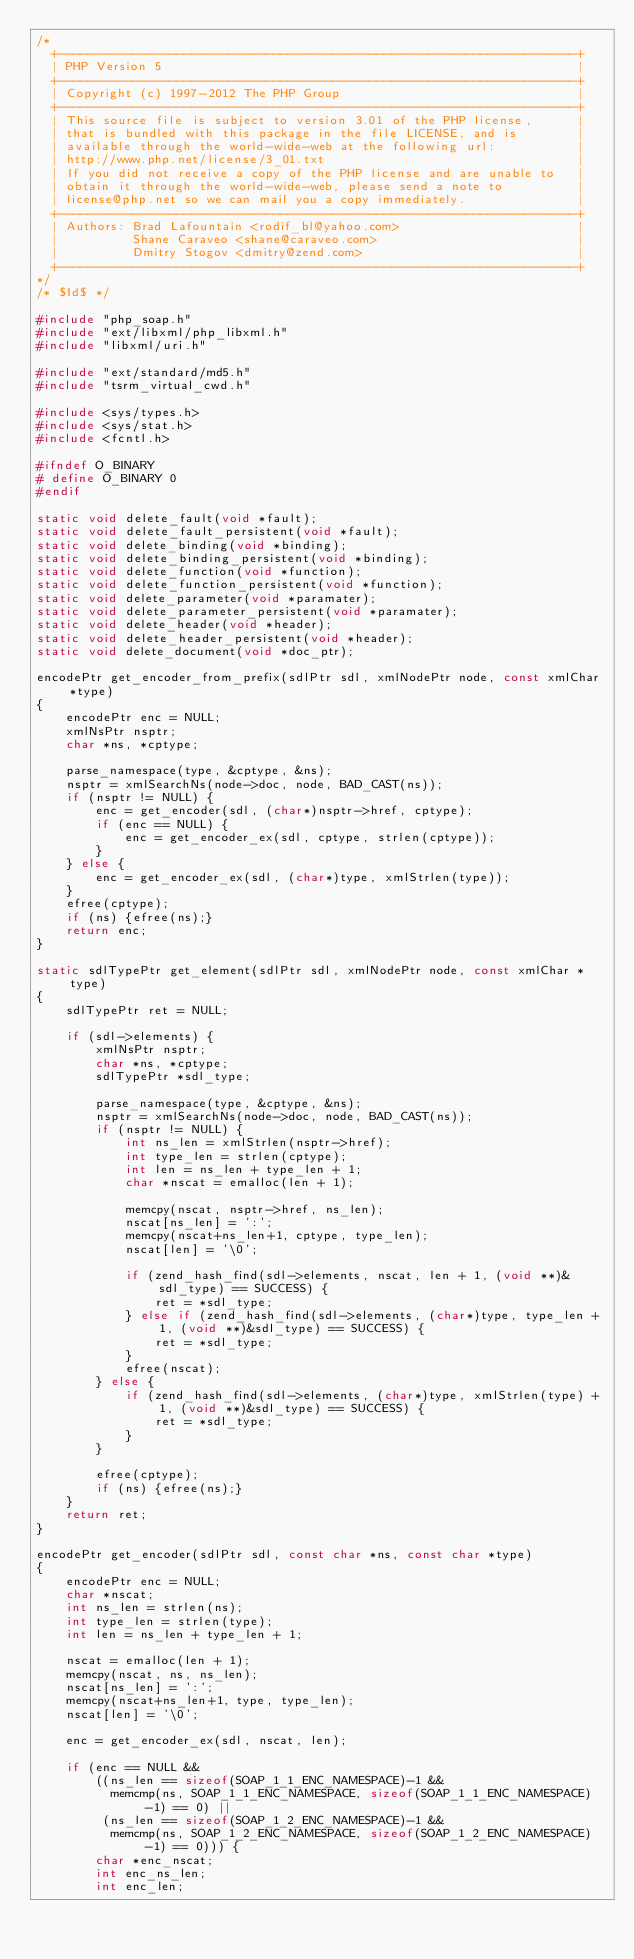Convert code to text. <code><loc_0><loc_0><loc_500><loc_500><_C_>/*
  +----------------------------------------------------------------------+
  | PHP Version 5                                                        |
  +----------------------------------------------------------------------+
  | Copyright (c) 1997-2012 The PHP Group                                |
  +----------------------------------------------------------------------+
  | This source file is subject to version 3.01 of the PHP license,      |
  | that is bundled with this package in the file LICENSE, and is        |
  | available through the world-wide-web at the following url:           |
  | http://www.php.net/license/3_01.txt                                  |
  | If you did not receive a copy of the PHP license and are unable to   |
  | obtain it through the world-wide-web, please send a note to          |
  | license@php.net so we can mail you a copy immediately.               |
  +----------------------------------------------------------------------+
  | Authors: Brad Lafountain <rodif_bl@yahoo.com>                        |
  |          Shane Caraveo <shane@caraveo.com>                           |
  |          Dmitry Stogov <dmitry@zend.com>                             |
  +----------------------------------------------------------------------+
*/
/* $Id$ */

#include "php_soap.h"
#include "ext/libxml/php_libxml.h"
#include "libxml/uri.h"

#include "ext/standard/md5.h"
#include "tsrm_virtual_cwd.h"

#include <sys/types.h>
#include <sys/stat.h>
#include <fcntl.h>

#ifndef O_BINARY
# define O_BINARY 0
#endif

static void delete_fault(void *fault);
static void delete_fault_persistent(void *fault);
static void delete_binding(void *binding);
static void delete_binding_persistent(void *binding);
static void delete_function(void *function);
static void delete_function_persistent(void *function);
static void delete_parameter(void *paramater);
static void delete_parameter_persistent(void *paramater);
static void delete_header(void *header);
static void delete_header_persistent(void *header);
static void delete_document(void *doc_ptr);

encodePtr get_encoder_from_prefix(sdlPtr sdl, xmlNodePtr node, const xmlChar *type)
{
	encodePtr enc = NULL;
	xmlNsPtr nsptr;
	char *ns, *cptype;

	parse_namespace(type, &cptype, &ns);
	nsptr = xmlSearchNs(node->doc, node, BAD_CAST(ns));
	if (nsptr != NULL) {
		enc = get_encoder(sdl, (char*)nsptr->href, cptype);
		if (enc == NULL) {
			enc = get_encoder_ex(sdl, cptype, strlen(cptype));
		}
	} else {
		enc = get_encoder_ex(sdl, (char*)type, xmlStrlen(type));
	}
	efree(cptype);
	if (ns) {efree(ns);}
	return enc;
}

static sdlTypePtr get_element(sdlPtr sdl, xmlNodePtr node, const xmlChar *type)
{
	sdlTypePtr ret = NULL;

	if (sdl->elements) {
		xmlNsPtr nsptr;
		char *ns, *cptype;
		sdlTypePtr *sdl_type;

		parse_namespace(type, &cptype, &ns);
		nsptr = xmlSearchNs(node->doc, node, BAD_CAST(ns));
		if (nsptr != NULL) {
			int ns_len = xmlStrlen(nsptr->href);
			int type_len = strlen(cptype);
			int len = ns_len + type_len + 1;
			char *nscat = emalloc(len + 1);

			memcpy(nscat, nsptr->href, ns_len);
			nscat[ns_len] = ':';
			memcpy(nscat+ns_len+1, cptype, type_len);
			nscat[len] = '\0';

			if (zend_hash_find(sdl->elements, nscat, len + 1, (void **)&sdl_type) == SUCCESS) {
				ret = *sdl_type;
			} else if (zend_hash_find(sdl->elements, (char*)type, type_len + 1, (void **)&sdl_type) == SUCCESS) {
				ret = *sdl_type;
			}
			efree(nscat);
		} else {
			if (zend_hash_find(sdl->elements, (char*)type, xmlStrlen(type) + 1, (void **)&sdl_type) == SUCCESS) {
				ret = *sdl_type;
			}
		}

		efree(cptype);
		if (ns) {efree(ns);}
	}
	return ret;
}

encodePtr get_encoder(sdlPtr sdl, const char *ns, const char *type)
{
	encodePtr enc = NULL;
	char *nscat;
	int ns_len = strlen(ns);
	int type_len = strlen(type);
	int len = ns_len + type_len + 1;

	nscat = emalloc(len + 1);
	memcpy(nscat, ns, ns_len);
	nscat[ns_len] = ':';
	memcpy(nscat+ns_len+1, type, type_len);
	nscat[len] = '\0';

	enc = get_encoder_ex(sdl, nscat, len);

	if (enc == NULL &&
	    ((ns_len == sizeof(SOAP_1_1_ENC_NAMESPACE)-1 &&
	      memcmp(ns, SOAP_1_1_ENC_NAMESPACE, sizeof(SOAP_1_1_ENC_NAMESPACE)-1) == 0) ||
	     (ns_len == sizeof(SOAP_1_2_ENC_NAMESPACE)-1 &&
	      memcmp(ns, SOAP_1_2_ENC_NAMESPACE, sizeof(SOAP_1_2_ENC_NAMESPACE)-1) == 0))) {
		char *enc_nscat;
		int enc_ns_len;
		int enc_len;
</code> 